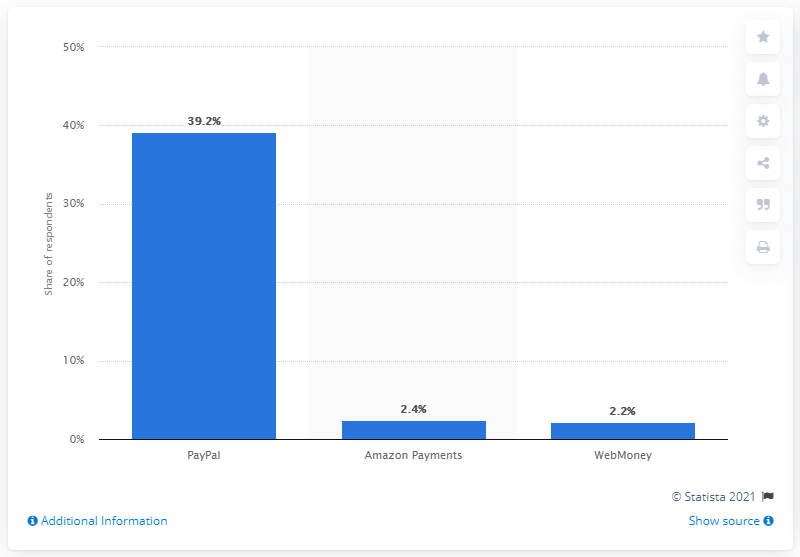Specify some key components in this picture. Thirty-nine percent of digital gamers chose PayPal as their top payment method for PC gaming content in the measured period. According to the provided data, PayPal was the preferred payment method for 39.2% of PC gamers. 